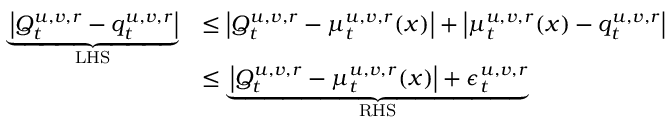<formula> <loc_0><loc_0><loc_500><loc_500>\begin{array} { r l } { \underbrace { \left | Q _ { t } ^ { u , v , r } - { q } _ { t } ^ { u , v , r } \right | } _ { L H S } } & { \leq \left | Q _ { t } ^ { u , v , r } - { \mu } _ { t } ^ { u , v , r } ( x ) \right | + \left | { \mu } _ { t } ^ { u , v , r } ( x ) - { q } _ { t } ^ { u , v , r } \right | } \\ & { \leq \underbrace { \left | Q _ { t } ^ { u , v , r } - { \mu } _ { t } ^ { u , v , r } ( x ) \right | + \epsilon _ { t } ^ { u , v , r } } _ { R H S } } \end{array}</formula> 